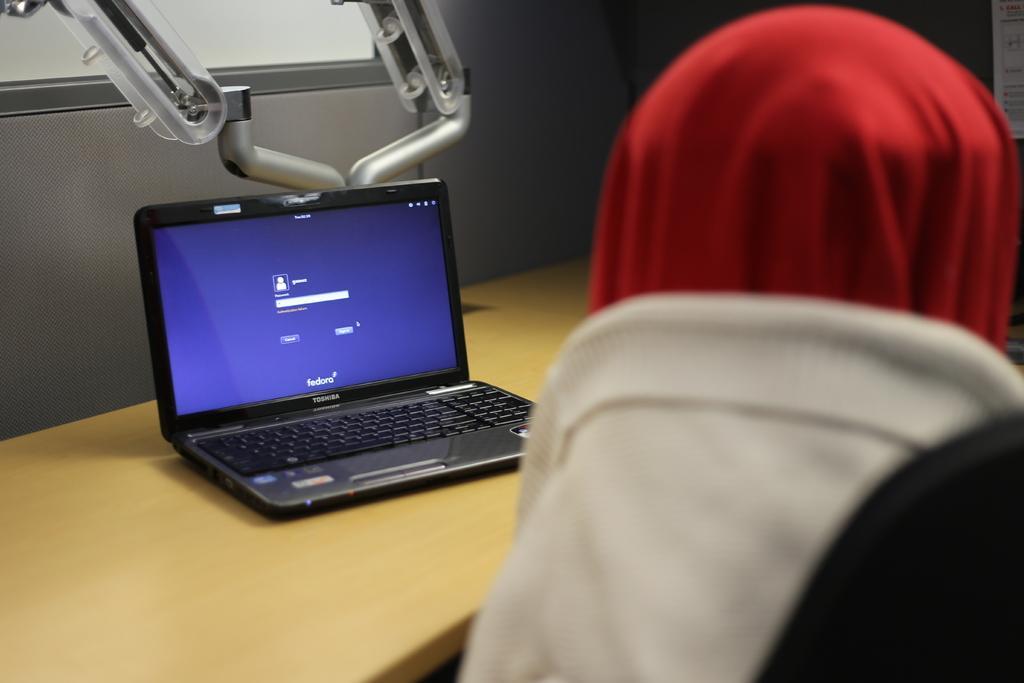Describe this image in one or two sentences. In this image I can see a laptop. Here I can see red and white colour thing. 